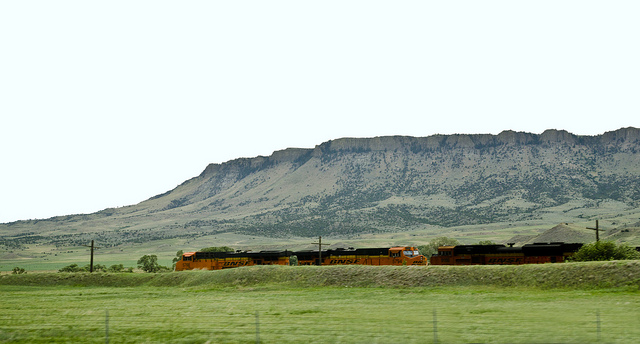<image>What do the yellow tags represent? I don't know what the yellow tags represent. It could be trains, shipping, stripes, or sale. What do the yellow tags represent? I don't know what the yellow tags represent. It can be trains, shipping, or something else. 